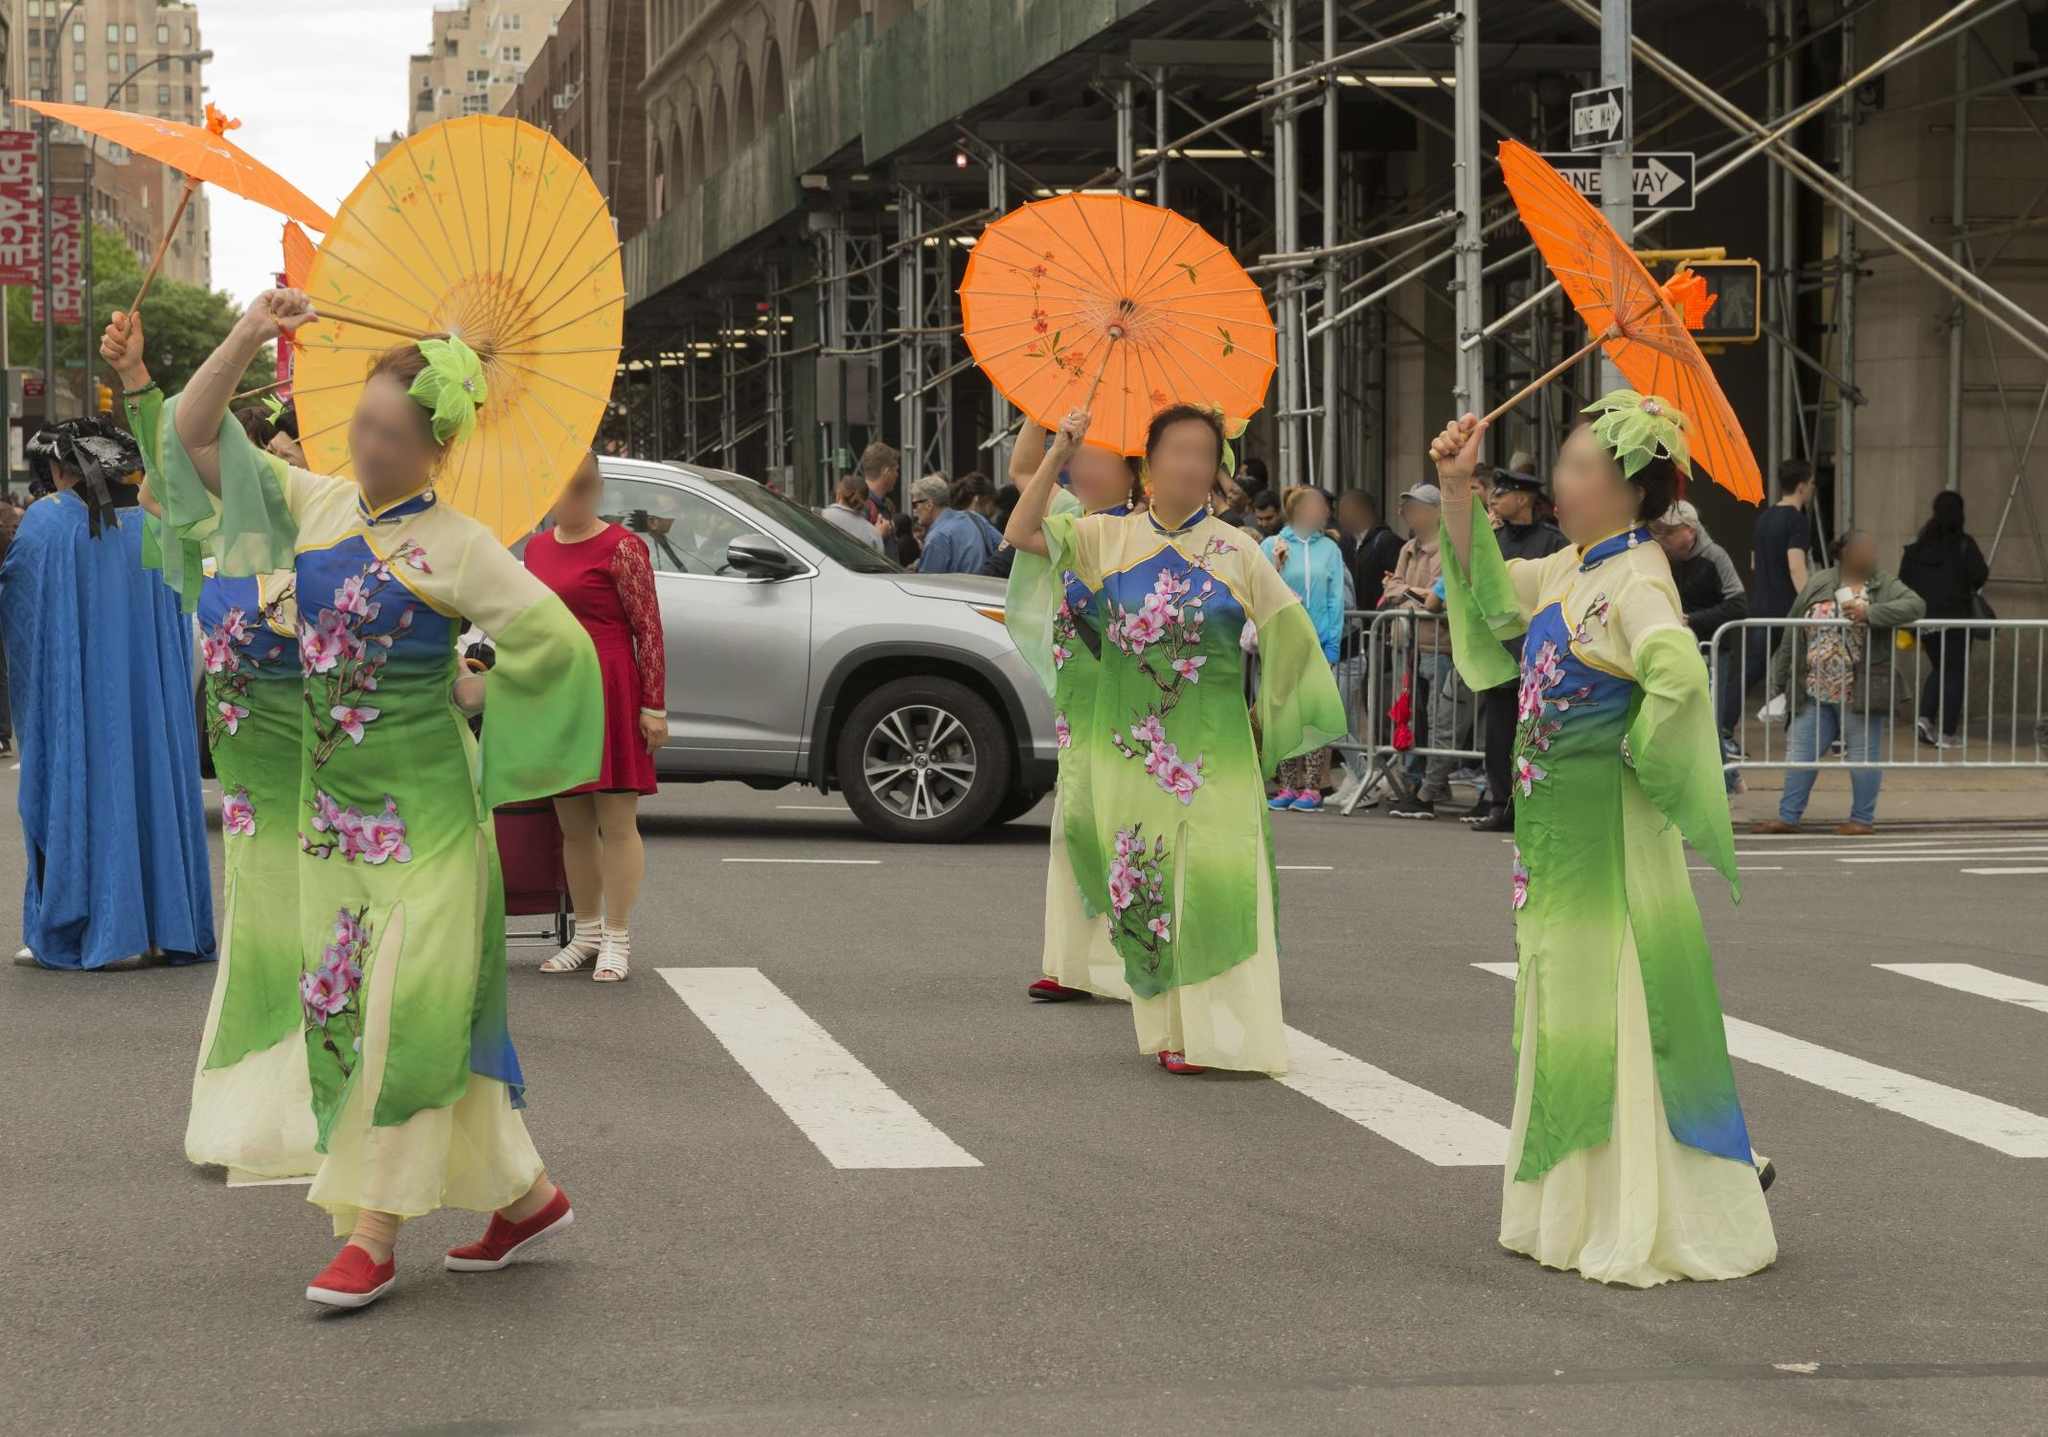Describe the cultural significance of the attire worn by the women in the image. The women in the image are wearing traditional kimonos, which hold deep cultural significance in East Asian, particularly Japanese, heritage. Kimonos are often worn on special occasions such as festivals, ceremonies, and parades, symbolizing respect for tradition and cultural heritage. The vibrant green color of the kimonos often represents youth, vigor, and the fresh energy of spring. The floral patterns enhance their beauty and are usually chosen for their seasonal or symbolic meanings. The parasols, often used as decorative items or to shield from the sun, add a layer of elegance and historical charm to the attire. 